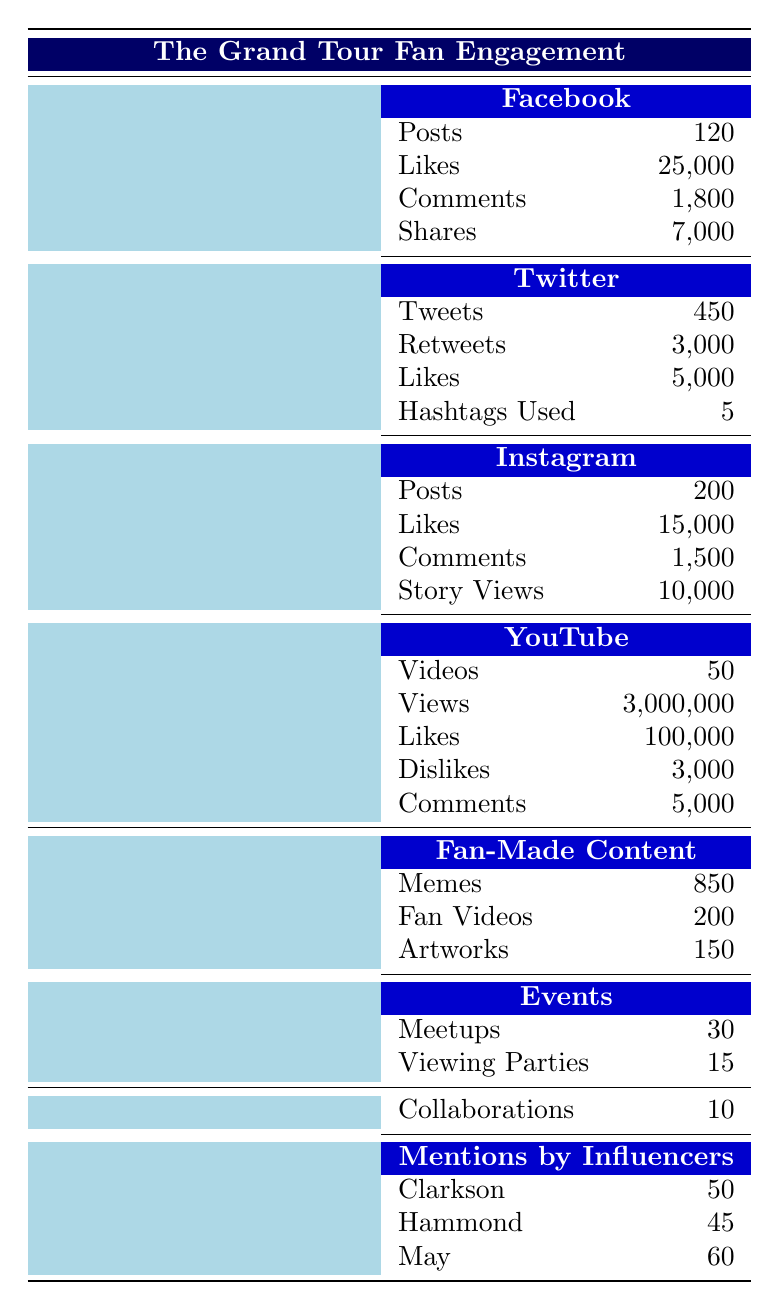What is the total number of likes across all social media platforms for The Grand Tour? To find the total number of likes, we sum the likes from each platform: Facebook (25,000) + Twitter (5,000) + Instagram (15,000) + YouTube (100,000) = 145,000.
Answer: 145,000 How many tweets were made about The Grand Tour? The total number of tweets on Twitter is listed as 450.
Answer: 450 Are there more memes or fan videos created by fans? There are 850 memes and 200 fan videos. Since 850 > 200, there are more memes.
Answer: Yes What percentage of Facebook posts were shared? To find the percentage of Facebook posts that were shared, we use the formula: (shares/posts) * 100 = (7,000 / 120) * 100 = 5833.33%.
Answer: 5833.33% What is the total number of interactions (likes, comments, shares) on Facebook? We add the likes, comments, and shares from Facebook: Likes (25,000) + Comments (1,800) + Shares (7,000) = 33,800.
Answer: 33,800 Is the number of views on YouTube greater than the total number of views on Instagram? YouTube has 3,000,000 views and Instagram has 10,000 story views. Since 3,000,000 > 10,000, YouTube's views are greater.
Answer: Yes How many more comments does YouTube have compared to Facebook? YouTube has 5,000 comments and Facebook has 1,800 comments. The difference is 5,000 - 1,800 = 3,200.
Answer: 3,200 What is the average number of likes across the four social media platforms? To find the average, we first sum the likes: Facebook (25,000) + Twitter (5,000) + Instagram (15,000) + YouTube (100,000) = 145,000. Then divide by 4, which gives 145,000 / 4 = 36,250.
Answer: 36,250 Which influencer received the highest number of mentions? The number of mentions is as follows: Clarkson (50), Hammond (45), May (60). Since May has the highest mentions with 60, he received the most.
Answer: May 